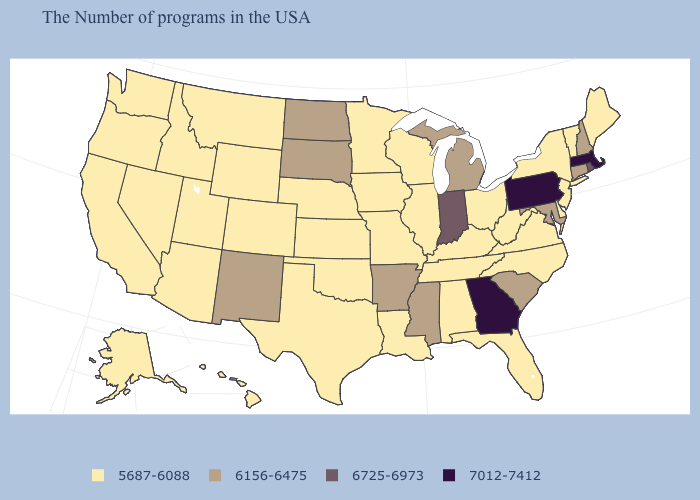Name the states that have a value in the range 7012-7412?
Answer briefly. Massachusetts, Pennsylvania, Georgia. What is the value of Massachusetts?
Answer briefly. 7012-7412. What is the lowest value in the USA?
Quick response, please. 5687-6088. Name the states that have a value in the range 6725-6973?
Quick response, please. Rhode Island, Indiana. Name the states that have a value in the range 6156-6475?
Short answer required. New Hampshire, Connecticut, Maryland, South Carolina, Michigan, Mississippi, Arkansas, South Dakota, North Dakota, New Mexico. What is the lowest value in the USA?
Keep it brief. 5687-6088. Which states have the lowest value in the MidWest?
Quick response, please. Ohio, Wisconsin, Illinois, Missouri, Minnesota, Iowa, Kansas, Nebraska. Name the states that have a value in the range 7012-7412?
Short answer required. Massachusetts, Pennsylvania, Georgia. Does Mississippi have the same value as Michigan?
Keep it brief. Yes. Name the states that have a value in the range 6156-6475?
Be succinct. New Hampshire, Connecticut, Maryland, South Carolina, Michigan, Mississippi, Arkansas, South Dakota, North Dakota, New Mexico. What is the lowest value in states that border Alabama?
Give a very brief answer. 5687-6088. What is the highest value in states that border Michigan?
Give a very brief answer. 6725-6973. Is the legend a continuous bar?
Give a very brief answer. No. What is the value of Arizona?
Answer briefly. 5687-6088. Name the states that have a value in the range 7012-7412?
Short answer required. Massachusetts, Pennsylvania, Georgia. 